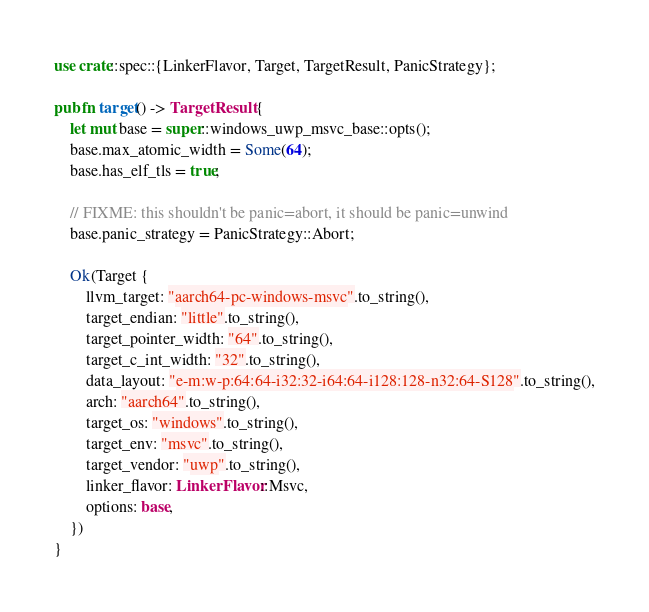<code> <loc_0><loc_0><loc_500><loc_500><_Rust_>use crate::spec::{LinkerFlavor, Target, TargetResult, PanicStrategy};

pub fn target() -> TargetResult {
    let mut base = super::windows_uwp_msvc_base::opts();
    base.max_atomic_width = Some(64);
    base.has_elf_tls = true;

    // FIXME: this shouldn't be panic=abort, it should be panic=unwind
    base.panic_strategy = PanicStrategy::Abort;

    Ok(Target {
        llvm_target: "aarch64-pc-windows-msvc".to_string(),
        target_endian: "little".to_string(),
        target_pointer_width: "64".to_string(),
        target_c_int_width: "32".to_string(),
        data_layout: "e-m:w-p:64:64-i32:32-i64:64-i128:128-n32:64-S128".to_string(),
        arch: "aarch64".to_string(),
        target_os: "windows".to_string(),
        target_env: "msvc".to_string(),
        target_vendor: "uwp".to_string(),
        linker_flavor: LinkerFlavor::Msvc,
        options: base,
    })
}
</code> 